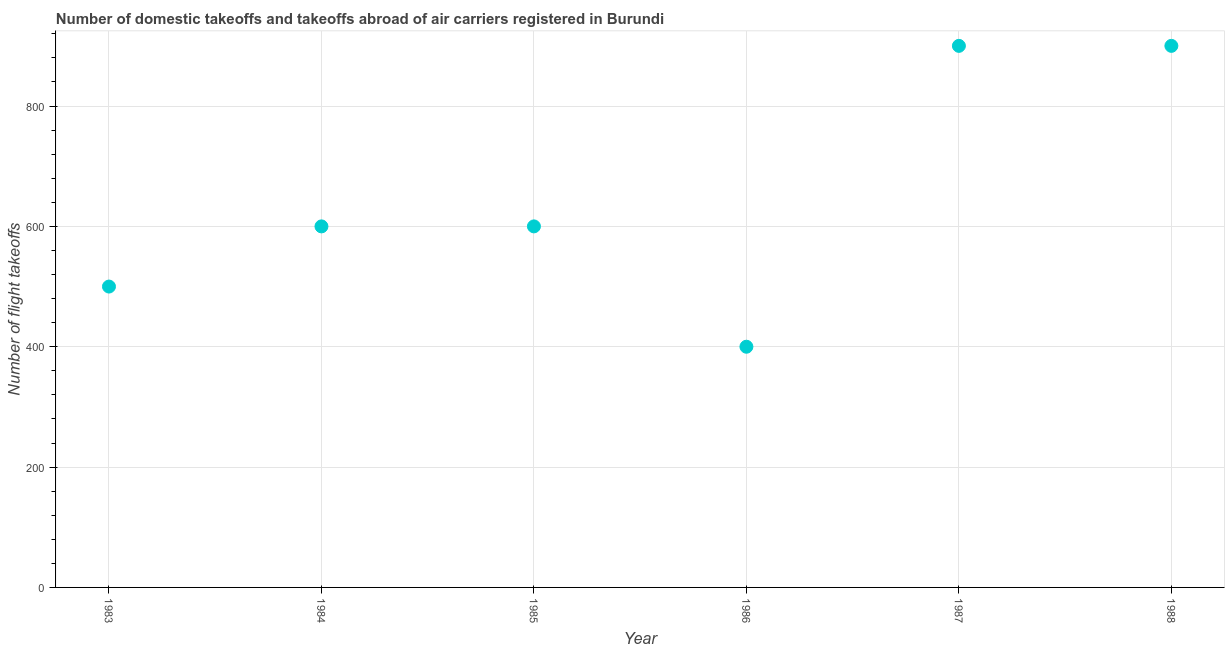What is the number of flight takeoffs in 1986?
Keep it short and to the point. 400. Across all years, what is the maximum number of flight takeoffs?
Keep it short and to the point. 900. Across all years, what is the minimum number of flight takeoffs?
Keep it short and to the point. 400. In which year was the number of flight takeoffs maximum?
Offer a very short reply. 1987. What is the sum of the number of flight takeoffs?
Provide a short and direct response. 3900. What is the difference between the number of flight takeoffs in 1983 and 1986?
Provide a short and direct response. 100. What is the average number of flight takeoffs per year?
Make the answer very short. 650. What is the median number of flight takeoffs?
Keep it short and to the point. 600. What is the ratio of the number of flight takeoffs in 1983 to that in 1988?
Provide a short and direct response. 0.56. Is the number of flight takeoffs in 1984 less than that in 1986?
Keep it short and to the point. No. What is the difference between the highest and the second highest number of flight takeoffs?
Give a very brief answer. 0. Is the sum of the number of flight takeoffs in 1984 and 1986 greater than the maximum number of flight takeoffs across all years?
Give a very brief answer. Yes. What is the difference between the highest and the lowest number of flight takeoffs?
Provide a succinct answer. 500. Does the number of flight takeoffs monotonically increase over the years?
Give a very brief answer. No. How many dotlines are there?
Give a very brief answer. 1. Are the values on the major ticks of Y-axis written in scientific E-notation?
Ensure brevity in your answer.  No. What is the title of the graph?
Ensure brevity in your answer.  Number of domestic takeoffs and takeoffs abroad of air carriers registered in Burundi. What is the label or title of the Y-axis?
Provide a succinct answer. Number of flight takeoffs. What is the Number of flight takeoffs in 1984?
Ensure brevity in your answer.  600. What is the Number of flight takeoffs in 1985?
Offer a terse response. 600. What is the Number of flight takeoffs in 1986?
Keep it short and to the point. 400. What is the Number of flight takeoffs in 1987?
Your answer should be very brief. 900. What is the Number of flight takeoffs in 1988?
Give a very brief answer. 900. What is the difference between the Number of flight takeoffs in 1983 and 1984?
Provide a short and direct response. -100. What is the difference between the Number of flight takeoffs in 1983 and 1985?
Provide a succinct answer. -100. What is the difference between the Number of flight takeoffs in 1983 and 1986?
Your answer should be compact. 100. What is the difference between the Number of flight takeoffs in 1983 and 1987?
Your answer should be compact. -400. What is the difference between the Number of flight takeoffs in 1983 and 1988?
Make the answer very short. -400. What is the difference between the Number of flight takeoffs in 1984 and 1985?
Your answer should be compact. 0. What is the difference between the Number of flight takeoffs in 1984 and 1986?
Offer a terse response. 200. What is the difference between the Number of flight takeoffs in 1984 and 1987?
Give a very brief answer. -300. What is the difference between the Number of flight takeoffs in 1984 and 1988?
Ensure brevity in your answer.  -300. What is the difference between the Number of flight takeoffs in 1985 and 1986?
Offer a terse response. 200. What is the difference between the Number of flight takeoffs in 1985 and 1987?
Give a very brief answer. -300. What is the difference between the Number of flight takeoffs in 1985 and 1988?
Provide a succinct answer. -300. What is the difference between the Number of flight takeoffs in 1986 and 1987?
Keep it short and to the point. -500. What is the difference between the Number of flight takeoffs in 1986 and 1988?
Make the answer very short. -500. What is the difference between the Number of flight takeoffs in 1987 and 1988?
Offer a terse response. 0. What is the ratio of the Number of flight takeoffs in 1983 to that in 1984?
Offer a very short reply. 0.83. What is the ratio of the Number of flight takeoffs in 1983 to that in 1985?
Your answer should be compact. 0.83. What is the ratio of the Number of flight takeoffs in 1983 to that in 1986?
Give a very brief answer. 1.25. What is the ratio of the Number of flight takeoffs in 1983 to that in 1987?
Give a very brief answer. 0.56. What is the ratio of the Number of flight takeoffs in 1983 to that in 1988?
Keep it short and to the point. 0.56. What is the ratio of the Number of flight takeoffs in 1984 to that in 1986?
Ensure brevity in your answer.  1.5. What is the ratio of the Number of flight takeoffs in 1984 to that in 1987?
Your answer should be compact. 0.67. What is the ratio of the Number of flight takeoffs in 1984 to that in 1988?
Make the answer very short. 0.67. What is the ratio of the Number of flight takeoffs in 1985 to that in 1987?
Ensure brevity in your answer.  0.67. What is the ratio of the Number of flight takeoffs in 1985 to that in 1988?
Ensure brevity in your answer.  0.67. What is the ratio of the Number of flight takeoffs in 1986 to that in 1987?
Provide a short and direct response. 0.44. What is the ratio of the Number of flight takeoffs in 1986 to that in 1988?
Ensure brevity in your answer.  0.44. 